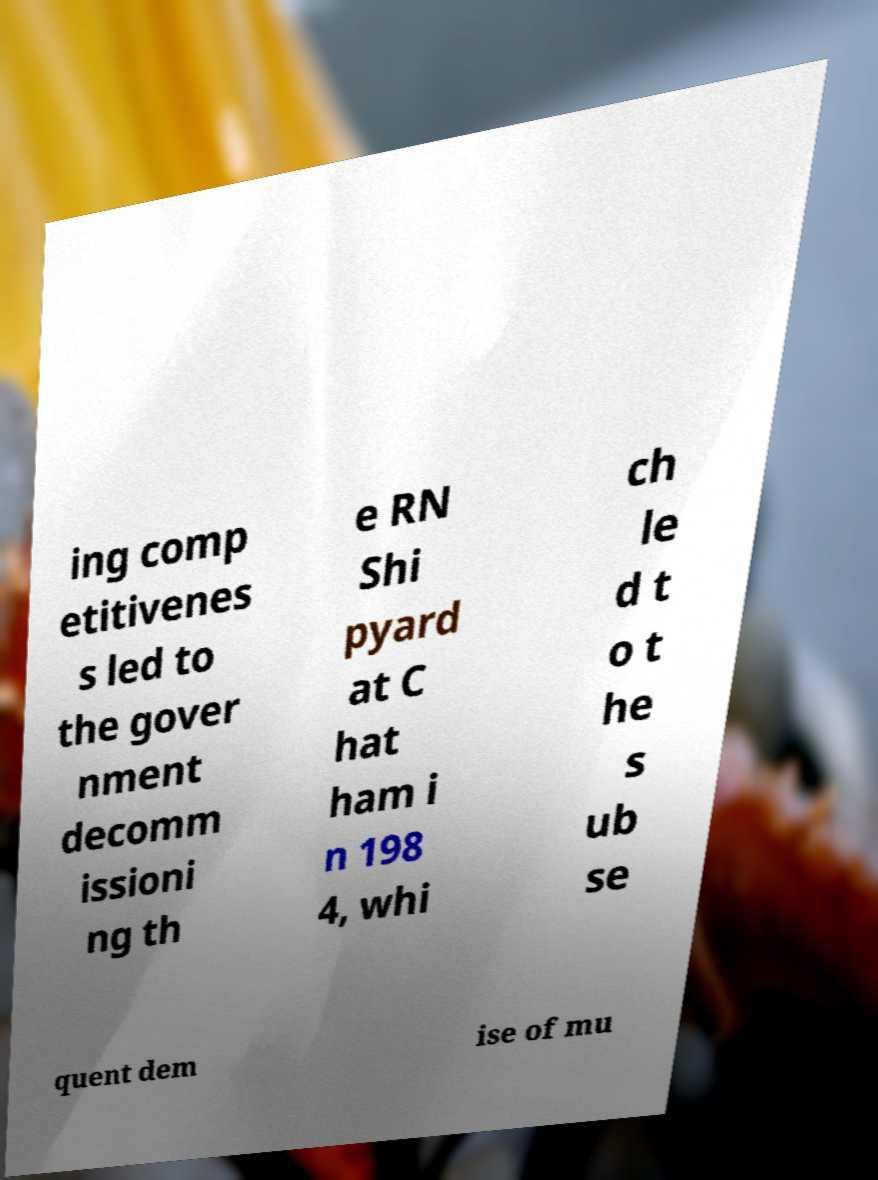What messages or text are displayed in this image? I need them in a readable, typed format. ing comp etitivenes s led to the gover nment decomm issioni ng th e RN Shi pyard at C hat ham i n 198 4, whi ch le d t o t he s ub se quent dem ise of mu 